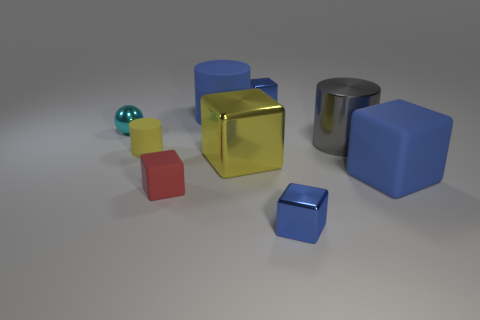Subtract all cyan balls. How many blue cubes are left? 3 Subtract all matte cubes. How many cubes are left? 3 Subtract all yellow cubes. How many cubes are left? 4 Subtract 2 blocks. How many blocks are left? 3 Add 1 tiny red matte objects. How many objects exist? 10 Subtract all brown cylinders. Subtract all brown spheres. How many cylinders are left? 3 Subtract all blocks. How many objects are left? 4 Add 7 yellow objects. How many yellow objects exist? 9 Subtract 0 purple spheres. How many objects are left? 9 Subtract all large blue balls. Subtract all small metal spheres. How many objects are left? 8 